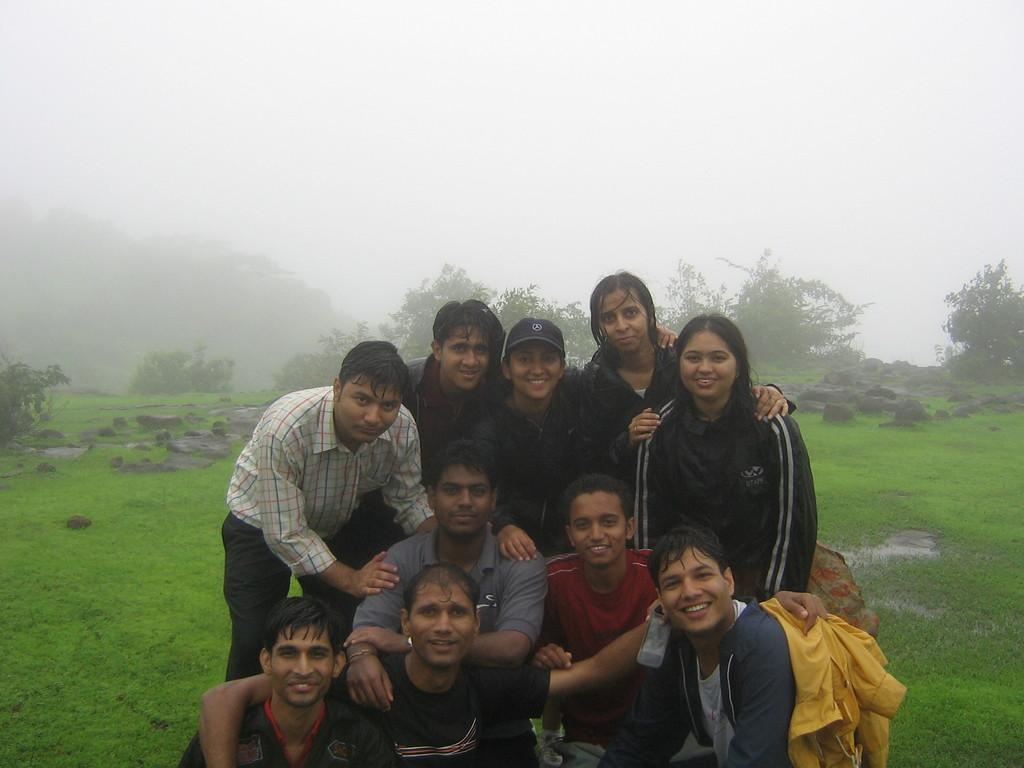What is located in the foreground of the image? There are people in the foreground of the image. What can be seen in the background of the image? There are trees, stones, grassland, and the sky visible in the background of the image. What type of fuel is being used by the people in the image? There is no indication in the image that the people are using any fuel, so it cannot be determined from the picture. 